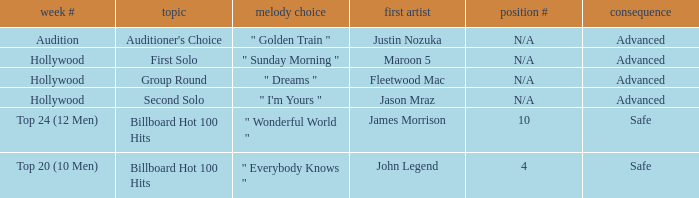Which topics involve a music preference for "golden train"? Auditioner's Choice. 